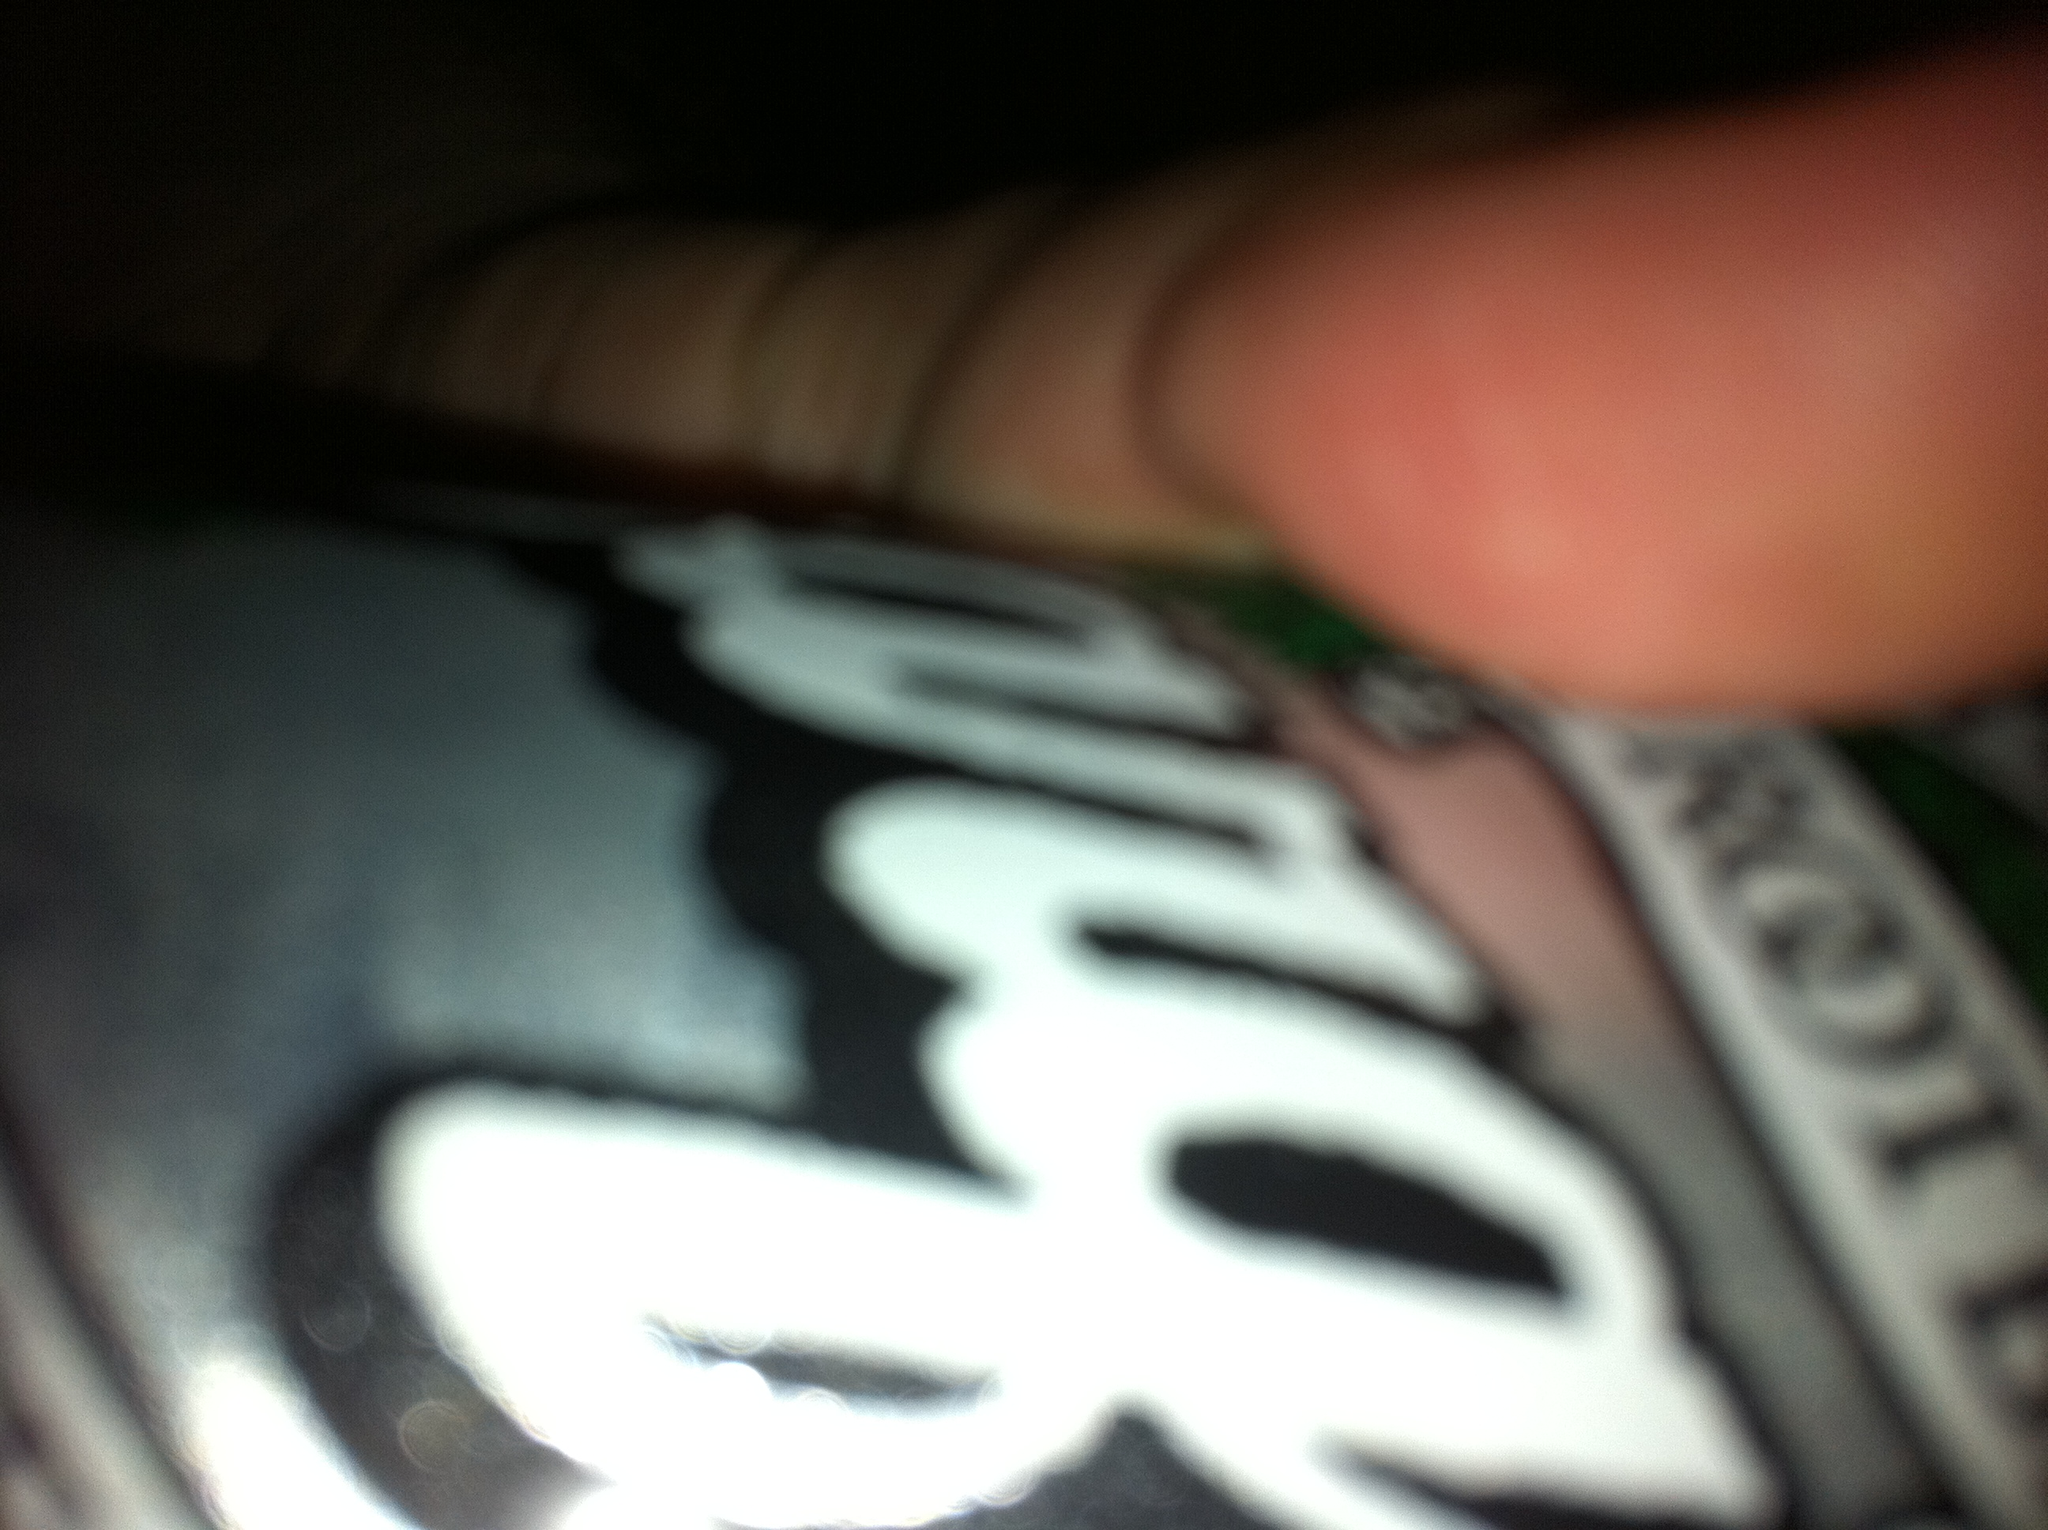If you could travel to a fantasy world where this root beer can has magical powers, what powers would it have? In a fantastical world, this can of root beer could grant its drinker the ability to control the weather. Imagine cracking open the can, and with each sip, you could summon a gentle rain to nourish the earth or command the sun to shine brighter on a cloudy day. The can itself might refit with mystical symbols that glow when the powers are activated, and it could be a revered artifact among those seeking to balance nature's elements. 